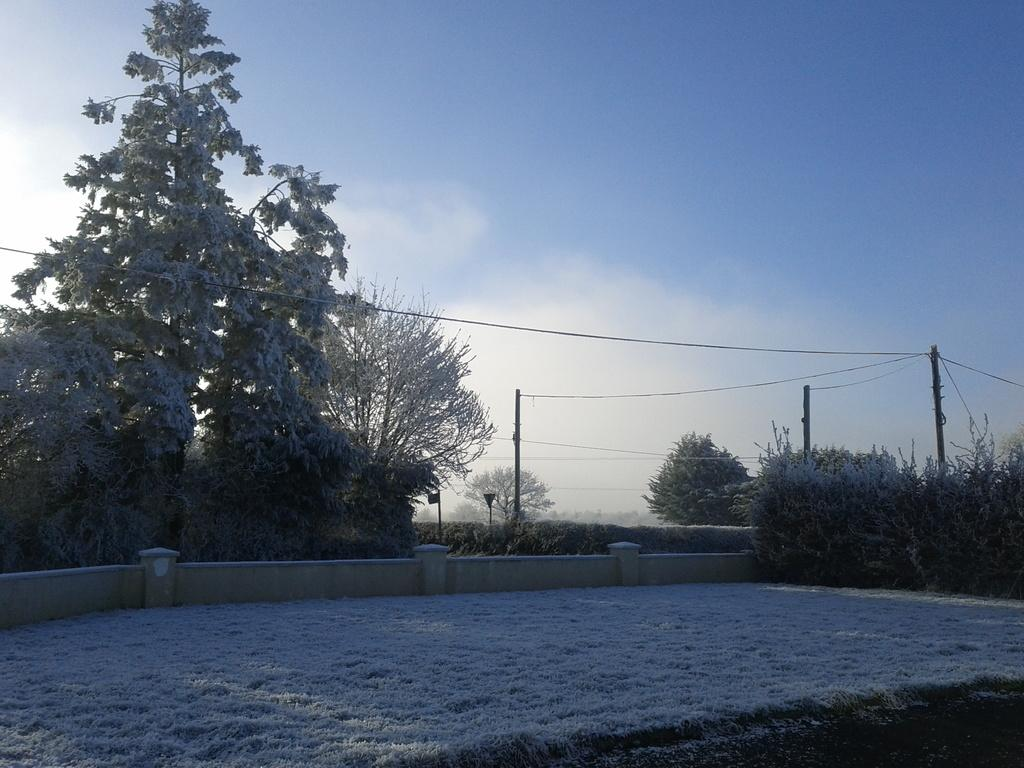What type of vegetation can be seen in the image? There is grass, plants, and trees visible in the image. What structures can be seen in the image? There are poles and a wall visible in the image. What is visible in the background of the image? The sky is visible in the background of the image. Who is the manager of the plants in the image? There is no indication of a manager in the image, as it features natural elements like grass, plants, and trees. What adjustments are being made to the front of the wall in the image? There are no adjustments being made to the wall in the image; it is a static structure. 